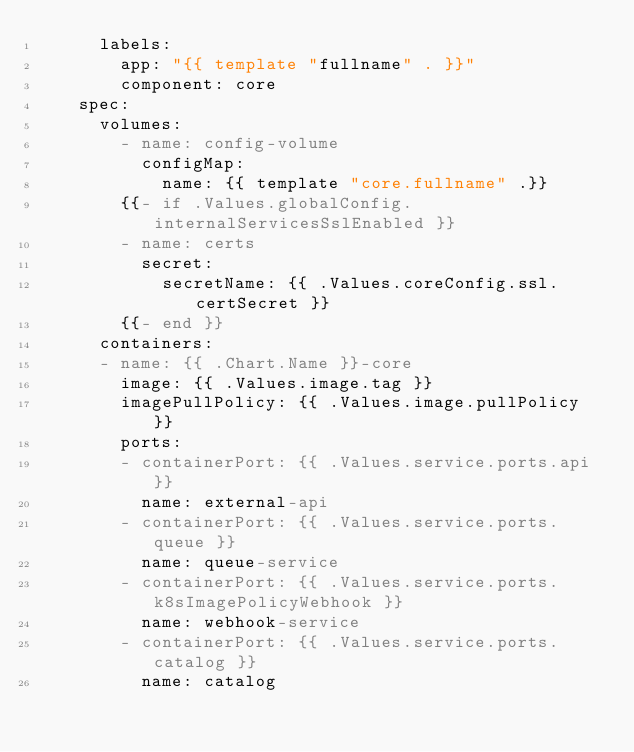<code> <loc_0><loc_0><loc_500><loc_500><_YAML_>      labels:
        app: "{{ template "fullname" . }}"
        component: core
    spec:
      volumes:
        - name: config-volume
          configMap:
            name: {{ template "core.fullname" .}}
        {{- if .Values.globalConfig.internalServicesSslEnabled }}
        - name: certs
          secret:
            secretName: {{ .Values.coreConfig.ssl.certSecret }}
        {{- end }}
      containers:
      - name: {{ .Chart.Name }}-core
        image: {{ .Values.image.tag }}
        imagePullPolicy: {{ .Values.image.pullPolicy }}
        ports:
        - containerPort: {{ .Values.service.ports.api }}
          name: external-api
        - containerPort: {{ .Values.service.ports.queue }}
          name: queue-service
        - containerPort: {{ .Values.service.ports.k8sImagePolicyWebhook }}
          name: webhook-service
        - containerPort: {{ .Values.service.ports.catalog }}
          name: catalog</code> 